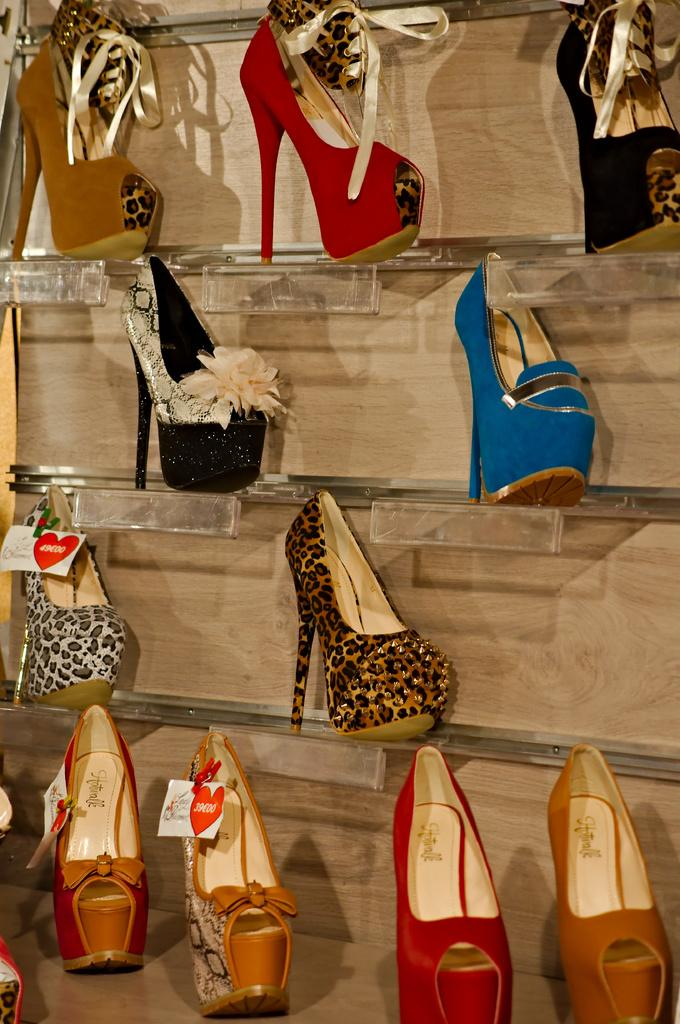What is the main subject of the image? The main subject of the image is many cells. How are the cells arranged in the image? The cells are arranged in a shelf. What type of noise can be heard coming from the cells in the image? There is no noise present in the image, as it features cells arranged in a shelf. Can you see a toothbrush in the image? There is no toothbrush present in the image. 